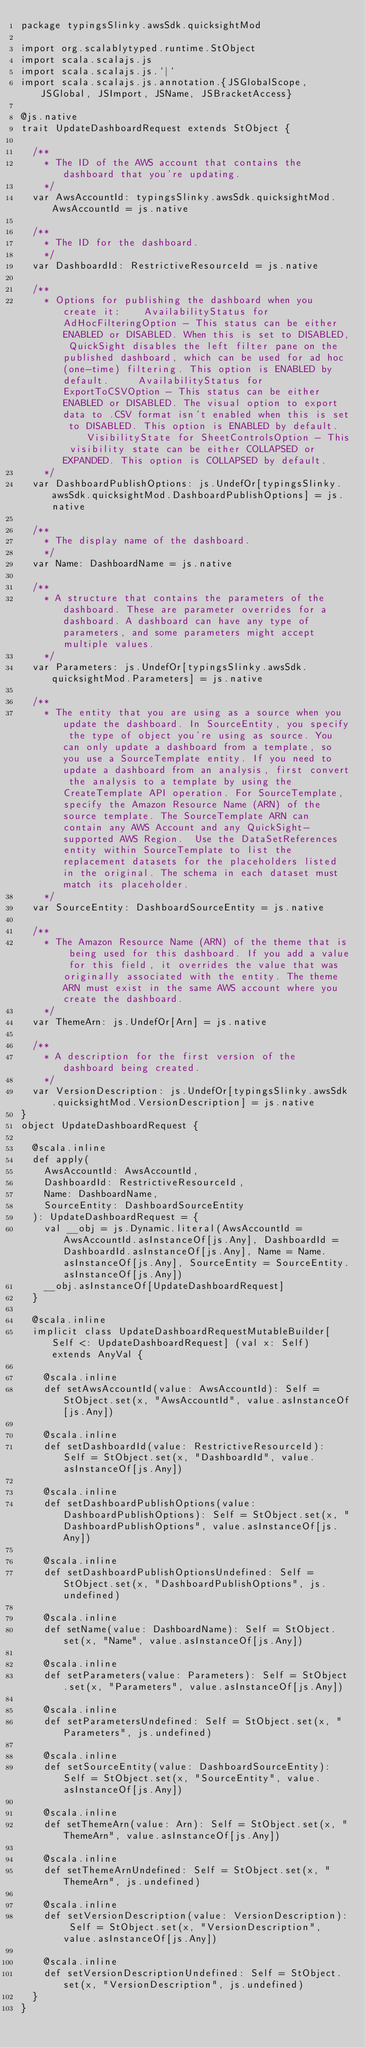<code> <loc_0><loc_0><loc_500><loc_500><_Scala_>package typingsSlinky.awsSdk.quicksightMod

import org.scalablytyped.runtime.StObject
import scala.scalajs.js
import scala.scalajs.js.`|`
import scala.scalajs.js.annotation.{JSGlobalScope, JSGlobal, JSImport, JSName, JSBracketAccess}

@js.native
trait UpdateDashboardRequest extends StObject {
  
  /**
    * The ID of the AWS account that contains the dashboard that you're updating.
    */
  var AwsAccountId: typingsSlinky.awsSdk.quicksightMod.AwsAccountId = js.native
  
  /**
    * The ID for the dashboard.
    */
  var DashboardId: RestrictiveResourceId = js.native
  
  /**
    * Options for publishing the dashboard when you create it:    AvailabilityStatus for AdHocFilteringOption - This status can be either ENABLED or DISABLED. When this is set to DISABLED, QuickSight disables the left filter pane on the published dashboard, which can be used for ad hoc (one-time) filtering. This option is ENABLED by default.     AvailabilityStatus for ExportToCSVOption - This status can be either ENABLED or DISABLED. The visual option to export data to .CSV format isn't enabled when this is set to DISABLED. This option is ENABLED by default.     VisibilityState for SheetControlsOption - This visibility state can be either COLLAPSED or EXPANDED. This option is COLLAPSED by default.   
    */
  var DashboardPublishOptions: js.UndefOr[typingsSlinky.awsSdk.quicksightMod.DashboardPublishOptions] = js.native
  
  /**
    * The display name of the dashboard.
    */
  var Name: DashboardName = js.native
  
  /**
    * A structure that contains the parameters of the dashboard. These are parameter overrides for a dashboard. A dashboard can have any type of parameters, and some parameters might accept multiple values.
    */
  var Parameters: js.UndefOr[typingsSlinky.awsSdk.quicksightMod.Parameters] = js.native
  
  /**
    * The entity that you are using as a source when you update the dashboard. In SourceEntity, you specify the type of object you're using as source. You can only update a dashboard from a template, so you use a SourceTemplate entity. If you need to update a dashboard from an analysis, first convert the analysis to a template by using the CreateTemplate API operation. For SourceTemplate, specify the Amazon Resource Name (ARN) of the source template. The SourceTemplate ARN can contain any AWS Account and any QuickSight-supported AWS Region.  Use the DataSetReferences entity within SourceTemplate to list the replacement datasets for the placeholders listed in the original. The schema in each dataset must match its placeholder. 
    */
  var SourceEntity: DashboardSourceEntity = js.native
  
  /**
    * The Amazon Resource Name (ARN) of the theme that is being used for this dashboard. If you add a value for this field, it overrides the value that was originally associated with the entity. The theme ARN must exist in the same AWS account where you create the dashboard.
    */
  var ThemeArn: js.UndefOr[Arn] = js.native
  
  /**
    * A description for the first version of the dashboard being created.
    */
  var VersionDescription: js.UndefOr[typingsSlinky.awsSdk.quicksightMod.VersionDescription] = js.native
}
object UpdateDashboardRequest {
  
  @scala.inline
  def apply(
    AwsAccountId: AwsAccountId,
    DashboardId: RestrictiveResourceId,
    Name: DashboardName,
    SourceEntity: DashboardSourceEntity
  ): UpdateDashboardRequest = {
    val __obj = js.Dynamic.literal(AwsAccountId = AwsAccountId.asInstanceOf[js.Any], DashboardId = DashboardId.asInstanceOf[js.Any], Name = Name.asInstanceOf[js.Any], SourceEntity = SourceEntity.asInstanceOf[js.Any])
    __obj.asInstanceOf[UpdateDashboardRequest]
  }
  
  @scala.inline
  implicit class UpdateDashboardRequestMutableBuilder[Self <: UpdateDashboardRequest] (val x: Self) extends AnyVal {
    
    @scala.inline
    def setAwsAccountId(value: AwsAccountId): Self = StObject.set(x, "AwsAccountId", value.asInstanceOf[js.Any])
    
    @scala.inline
    def setDashboardId(value: RestrictiveResourceId): Self = StObject.set(x, "DashboardId", value.asInstanceOf[js.Any])
    
    @scala.inline
    def setDashboardPublishOptions(value: DashboardPublishOptions): Self = StObject.set(x, "DashboardPublishOptions", value.asInstanceOf[js.Any])
    
    @scala.inline
    def setDashboardPublishOptionsUndefined: Self = StObject.set(x, "DashboardPublishOptions", js.undefined)
    
    @scala.inline
    def setName(value: DashboardName): Self = StObject.set(x, "Name", value.asInstanceOf[js.Any])
    
    @scala.inline
    def setParameters(value: Parameters): Self = StObject.set(x, "Parameters", value.asInstanceOf[js.Any])
    
    @scala.inline
    def setParametersUndefined: Self = StObject.set(x, "Parameters", js.undefined)
    
    @scala.inline
    def setSourceEntity(value: DashboardSourceEntity): Self = StObject.set(x, "SourceEntity", value.asInstanceOf[js.Any])
    
    @scala.inline
    def setThemeArn(value: Arn): Self = StObject.set(x, "ThemeArn", value.asInstanceOf[js.Any])
    
    @scala.inline
    def setThemeArnUndefined: Self = StObject.set(x, "ThemeArn", js.undefined)
    
    @scala.inline
    def setVersionDescription(value: VersionDescription): Self = StObject.set(x, "VersionDescription", value.asInstanceOf[js.Any])
    
    @scala.inline
    def setVersionDescriptionUndefined: Self = StObject.set(x, "VersionDescription", js.undefined)
  }
}
</code> 